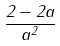Convert formula to latex. <formula><loc_0><loc_0><loc_500><loc_500>\frac { 2 - 2 a } { a ^ { 2 } }</formula> 